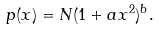Convert formula to latex. <formula><loc_0><loc_0><loc_500><loc_500>p ( x ) = N ( 1 + a x ^ { 2 } ) ^ { b } .</formula> 